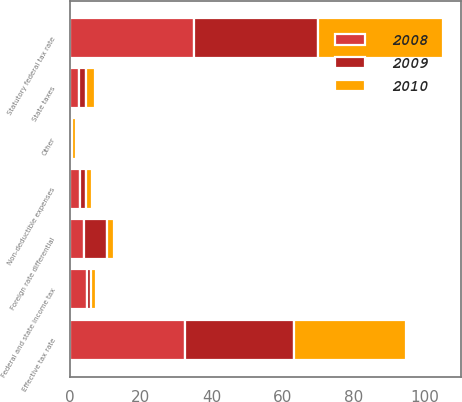<chart> <loc_0><loc_0><loc_500><loc_500><stacked_bar_chart><ecel><fcel>Statutory federal tax rate<fcel>Foreign rate differential<fcel>Federal and state income tax<fcel>State taxes<fcel>Non-deductible expenses<fcel>Other<fcel>Effective tax rate<nl><fcel>2010<fcel>35<fcel>1.9<fcel>1.5<fcel>2.6<fcel>1.6<fcel>1.1<fcel>31.5<nl><fcel>2008<fcel>35<fcel>4<fcel>4.7<fcel>2.6<fcel>3<fcel>0.5<fcel>32.4<nl><fcel>2009<fcel>35<fcel>6.6<fcel>1.2<fcel>1.9<fcel>1.6<fcel>0.1<fcel>30.8<nl></chart> 